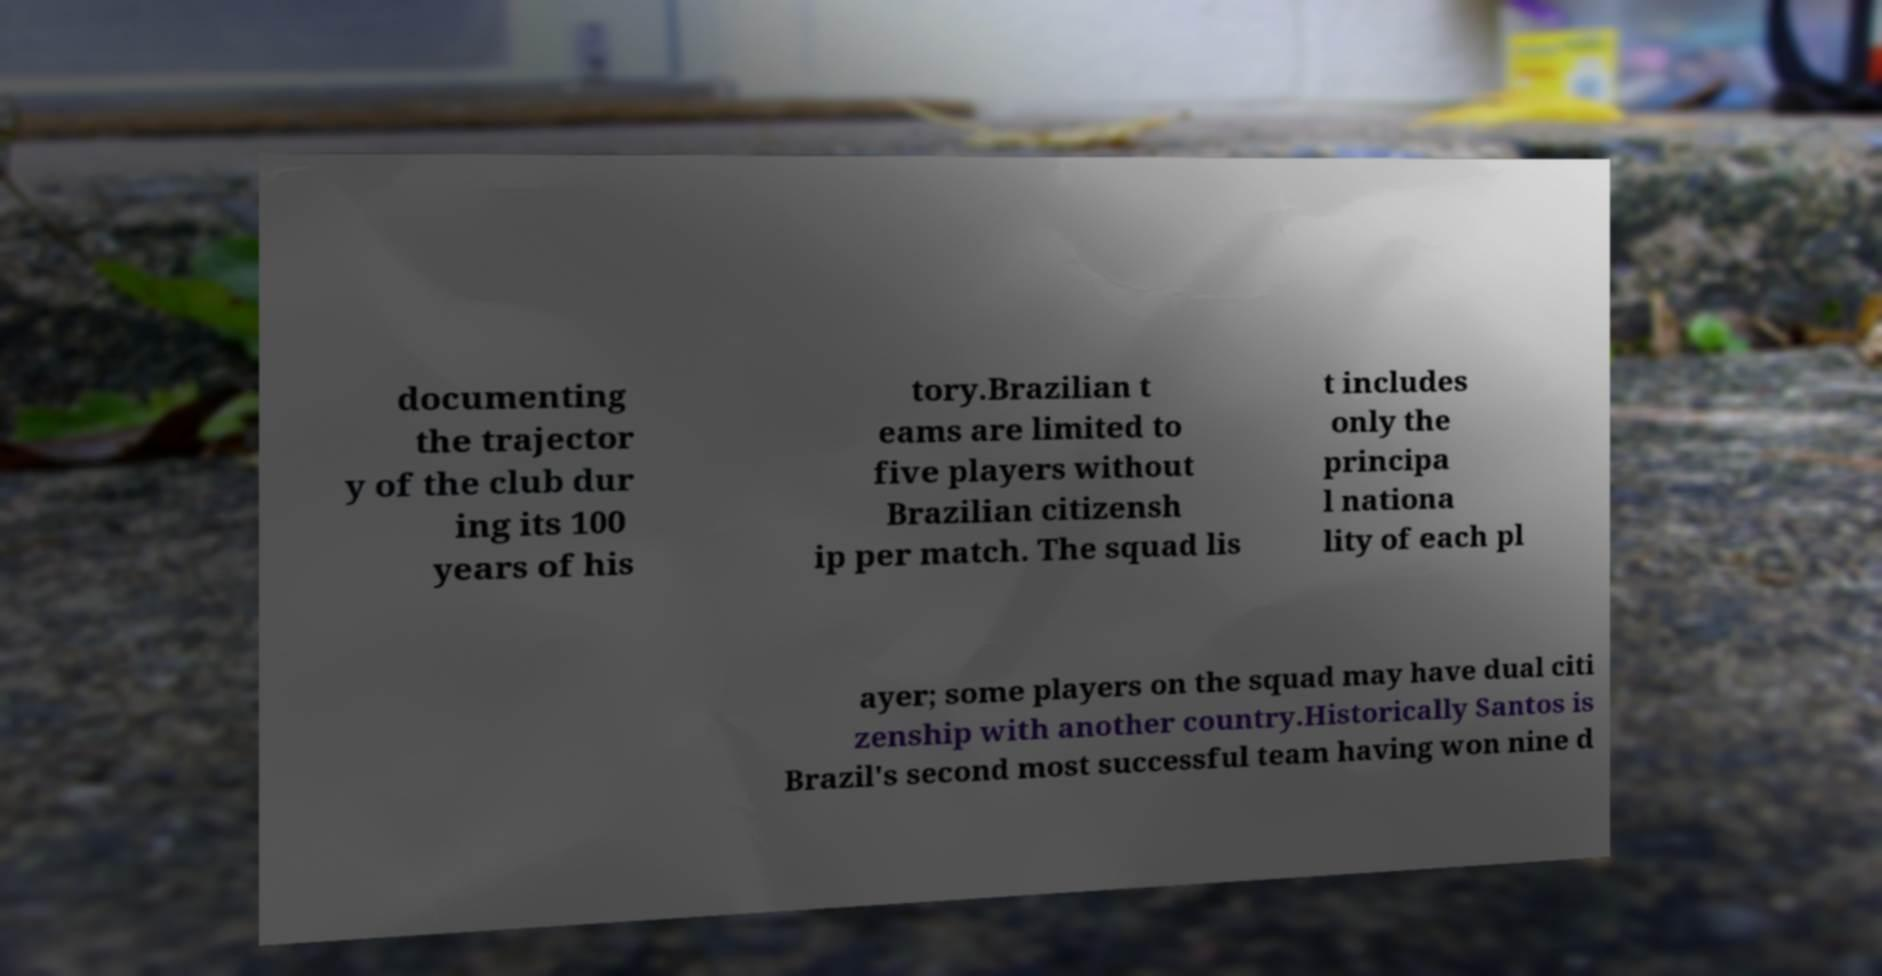There's text embedded in this image that I need extracted. Can you transcribe it verbatim? documenting the trajector y of the club dur ing its 100 years of his tory.Brazilian t eams are limited to five players without Brazilian citizensh ip per match. The squad lis t includes only the principa l nationa lity of each pl ayer; some players on the squad may have dual citi zenship with another country.Historically Santos is Brazil's second most successful team having won nine d 